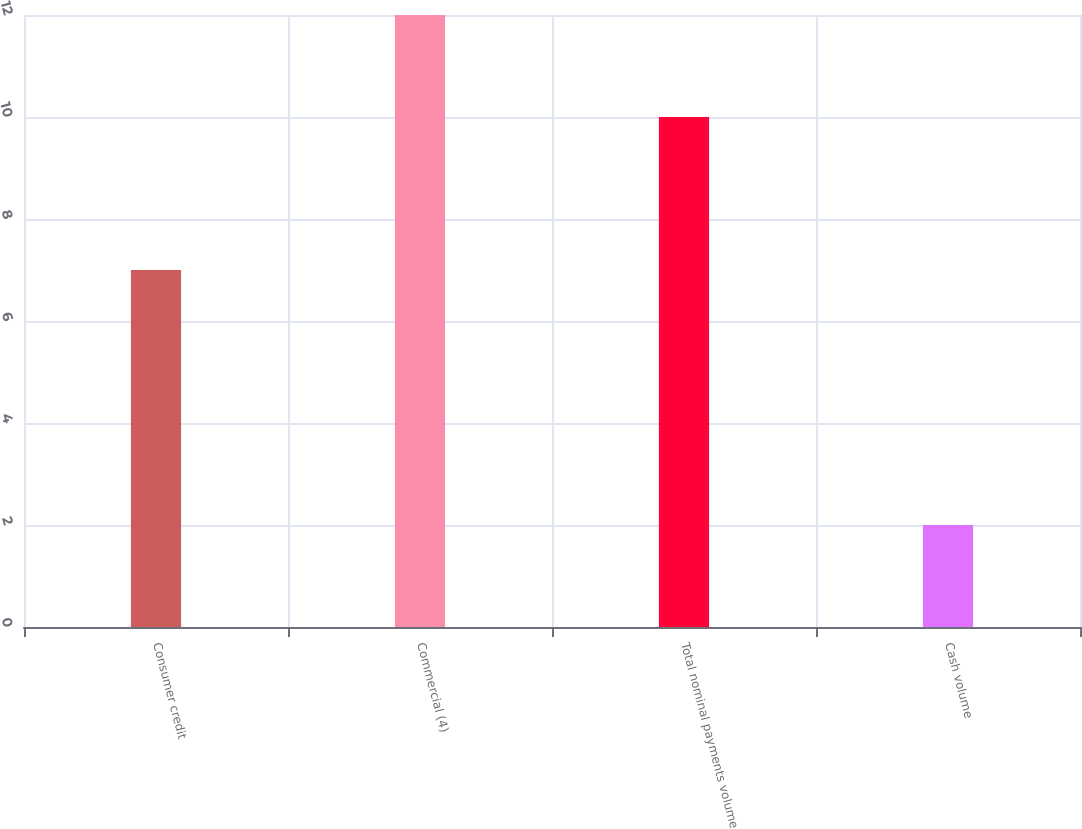Convert chart to OTSL. <chart><loc_0><loc_0><loc_500><loc_500><bar_chart><fcel>Consumer credit<fcel>Commercial (4)<fcel>Total nominal payments volume<fcel>Cash volume<nl><fcel>7<fcel>12<fcel>10<fcel>2<nl></chart> 